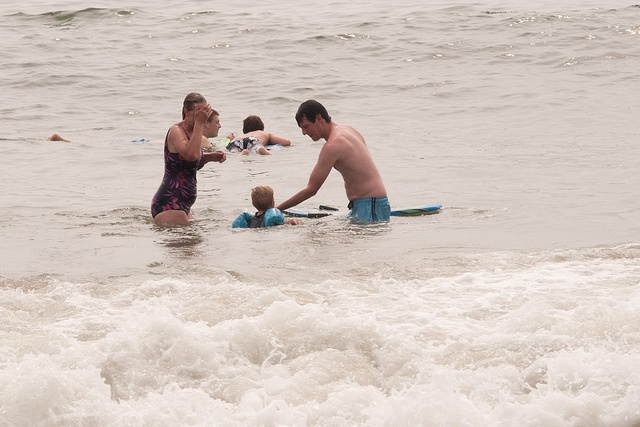Describe the objects in this image and their specific colors. I can see people in lightgray, brown, lightpink, and maroon tones, people in lightgray, black, brown, and maroon tones, people in lightgray, black, lightpink, and gray tones, people in lightgray, black, teal, gray, and maroon tones, and surfboard in lightgray, gray, black, and darkgray tones in this image. 